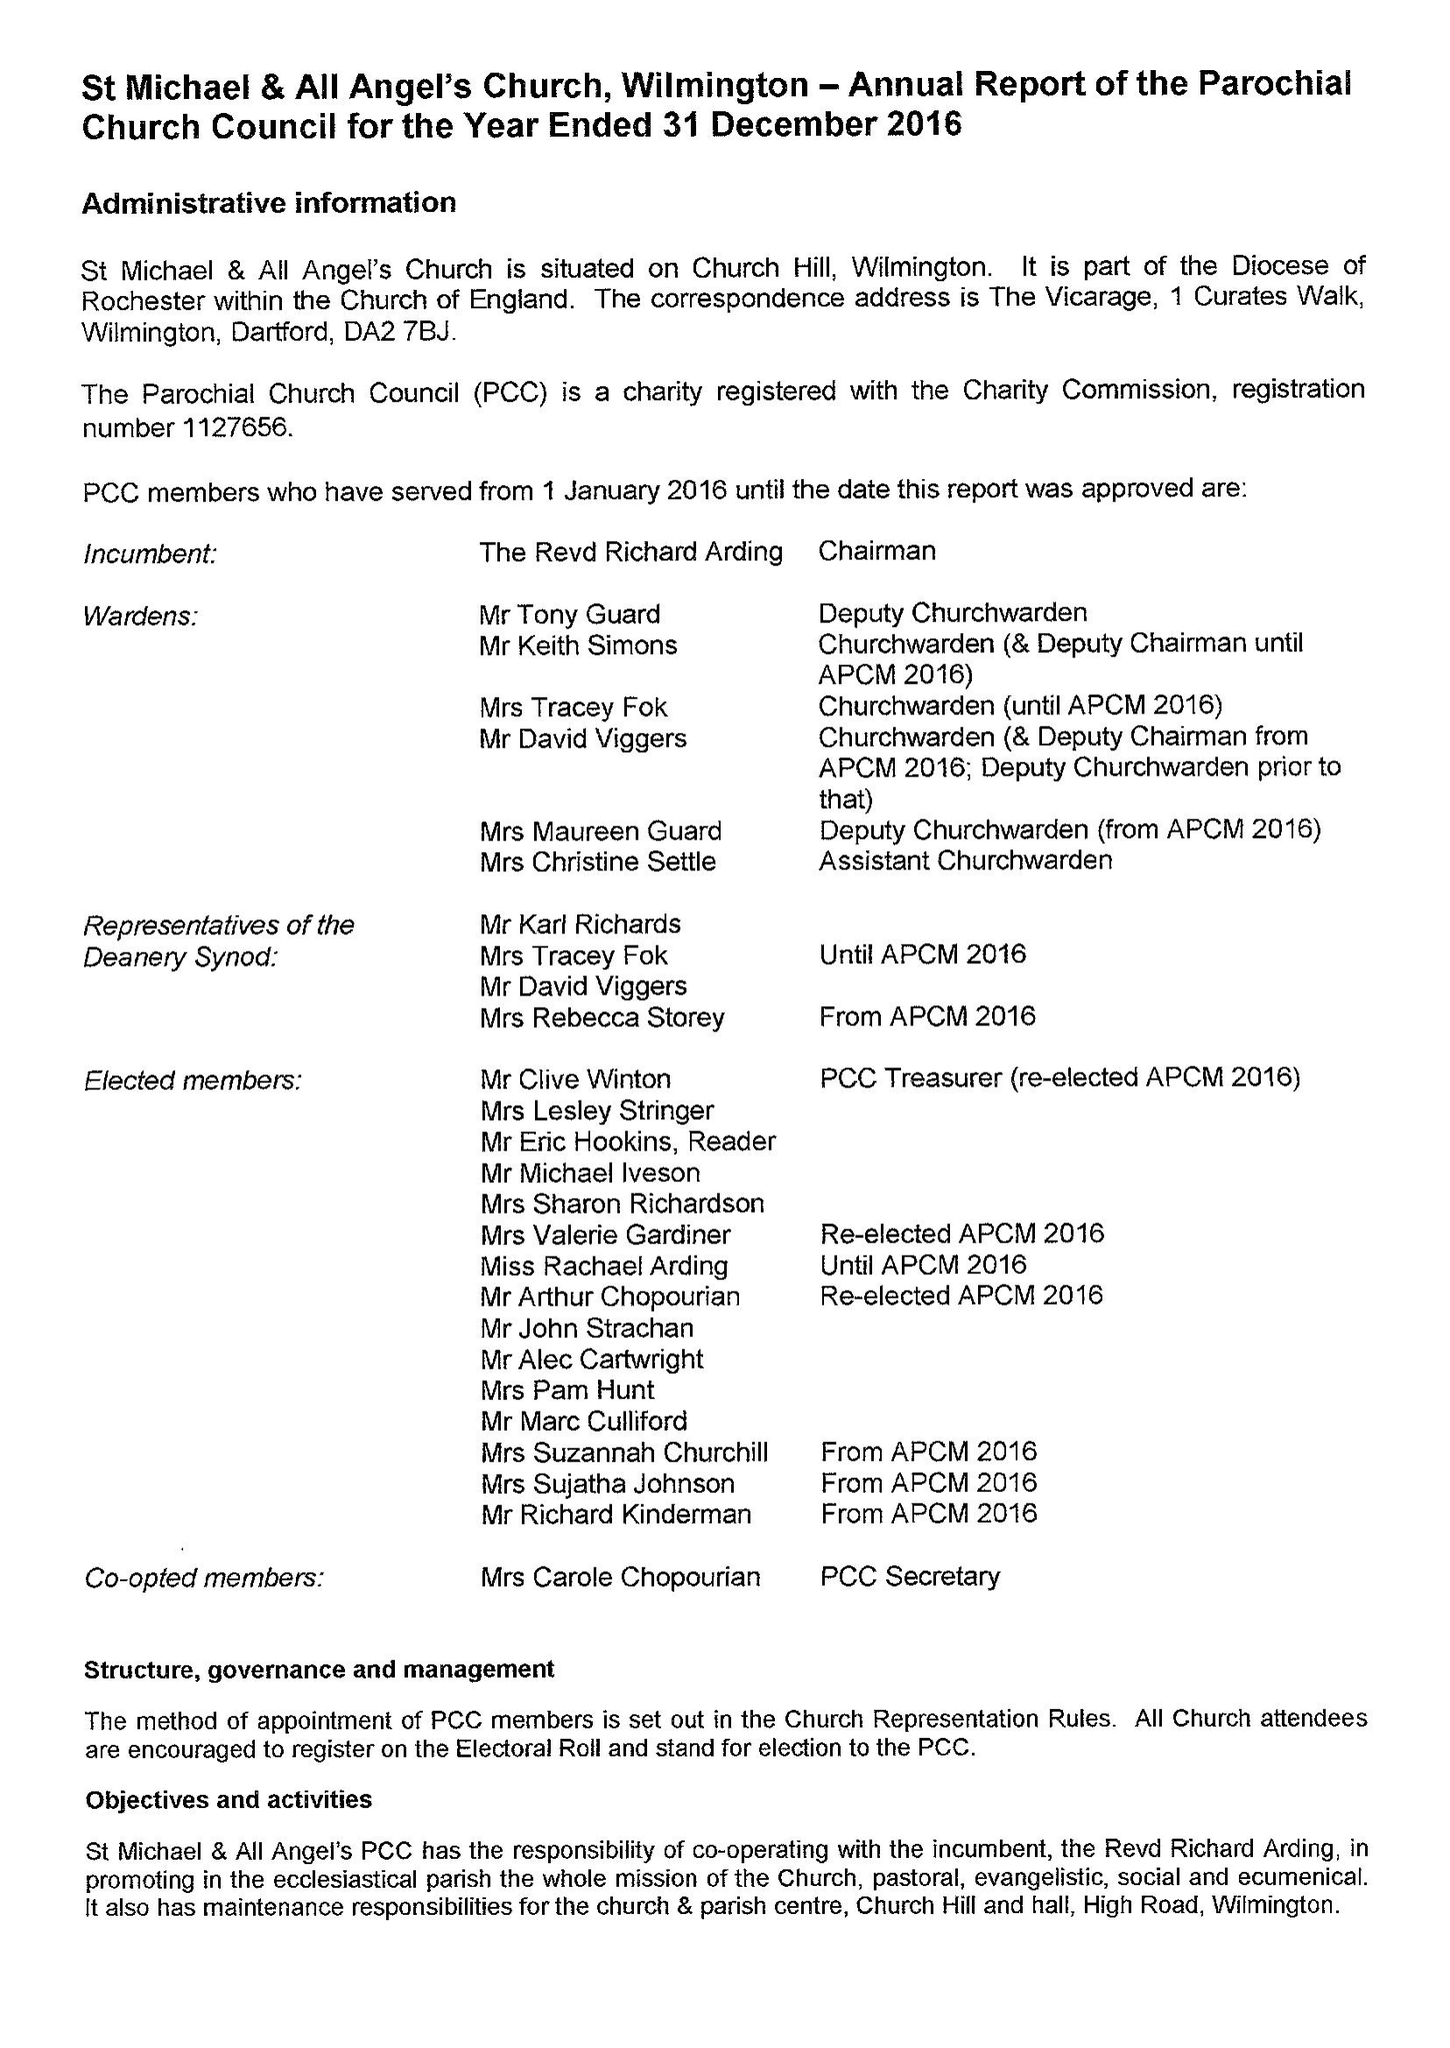What is the value for the income_annually_in_british_pounds?
Answer the question using a single word or phrase. 154492.00 